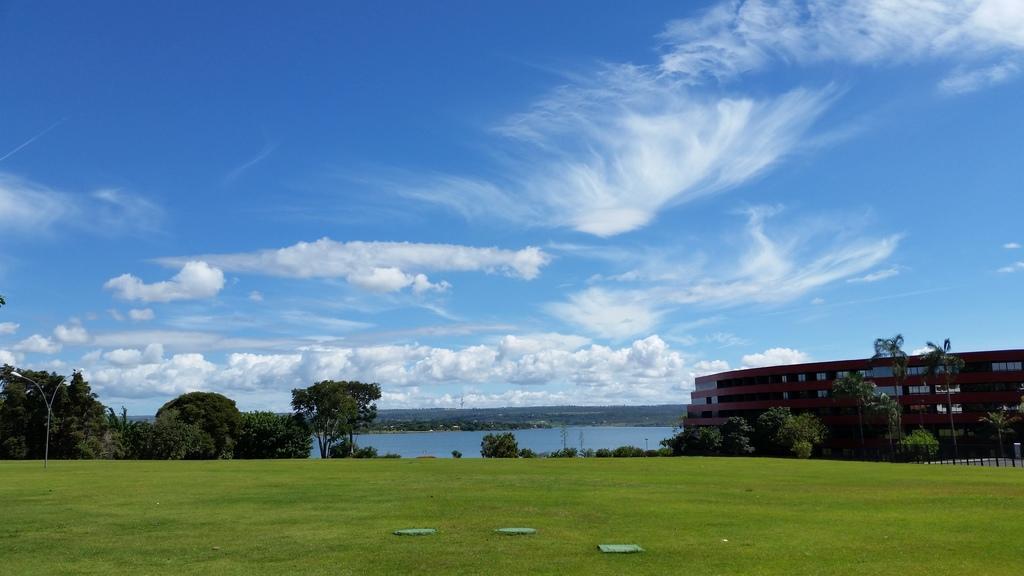Can you describe this image briefly? At the bottom of the picture, we see the grass and we see something in green color. On the left side, we see the streetlights and the trees. On the right side, we see the trees and a building in brown and grey color. In the background, we see water and this water might be in the pond. There are trees in the background. At the top, we see the sky and the clouds. 